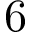<formula> <loc_0><loc_0><loc_500><loc_500>6</formula> 